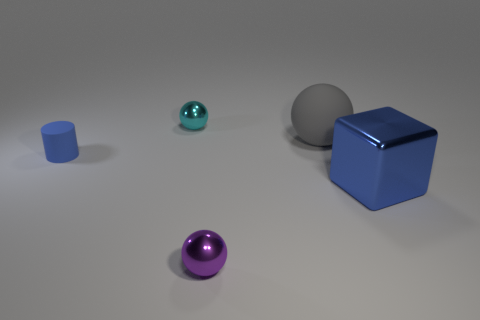What number of blocks are the same size as the cyan metal sphere?
Provide a succinct answer. 0. What is the color of the tiny matte object?
Your answer should be very brief. Blue. There is a large shiny thing; is it the same color as the tiny metallic ball in front of the gray rubber sphere?
Your answer should be compact. No. There is a purple sphere that is made of the same material as the block; what is its size?
Keep it short and to the point. Small. Are there any matte objects of the same color as the small rubber cylinder?
Keep it short and to the point. No. How many objects are metallic balls that are behind the large gray matte thing or gray spheres?
Give a very brief answer. 2. Does the tiny cylinder have the same material as the tiny object in front of the small rubber cylinder?
Make the answer very short. No. There is a matte thing that is the same color as the big shiny thing; what is its size?
Your answer should be very brief. Small. Are there any red cubes that have the same material as the small cyan ball?
Make the answer very short. No. What number of things are metallic balls to the right of the tiny cyan ball or tiny balls in front of the tiny cyan sphere?
Make the answer very short. 1. 